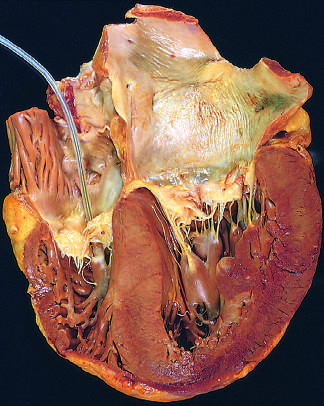what are shown on the right in this four-chamber view of the heart?
Answer the question using a single word or phrase. The left ventricle and left atrium 